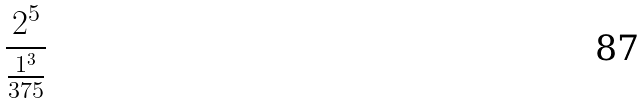<formula> <loc_0><loc_0><loc_500><loc_500>\frac { 2 ^ { 5 } } { \frac { 1 ^ { 3 } } { 3 7 5 } }</formula> 